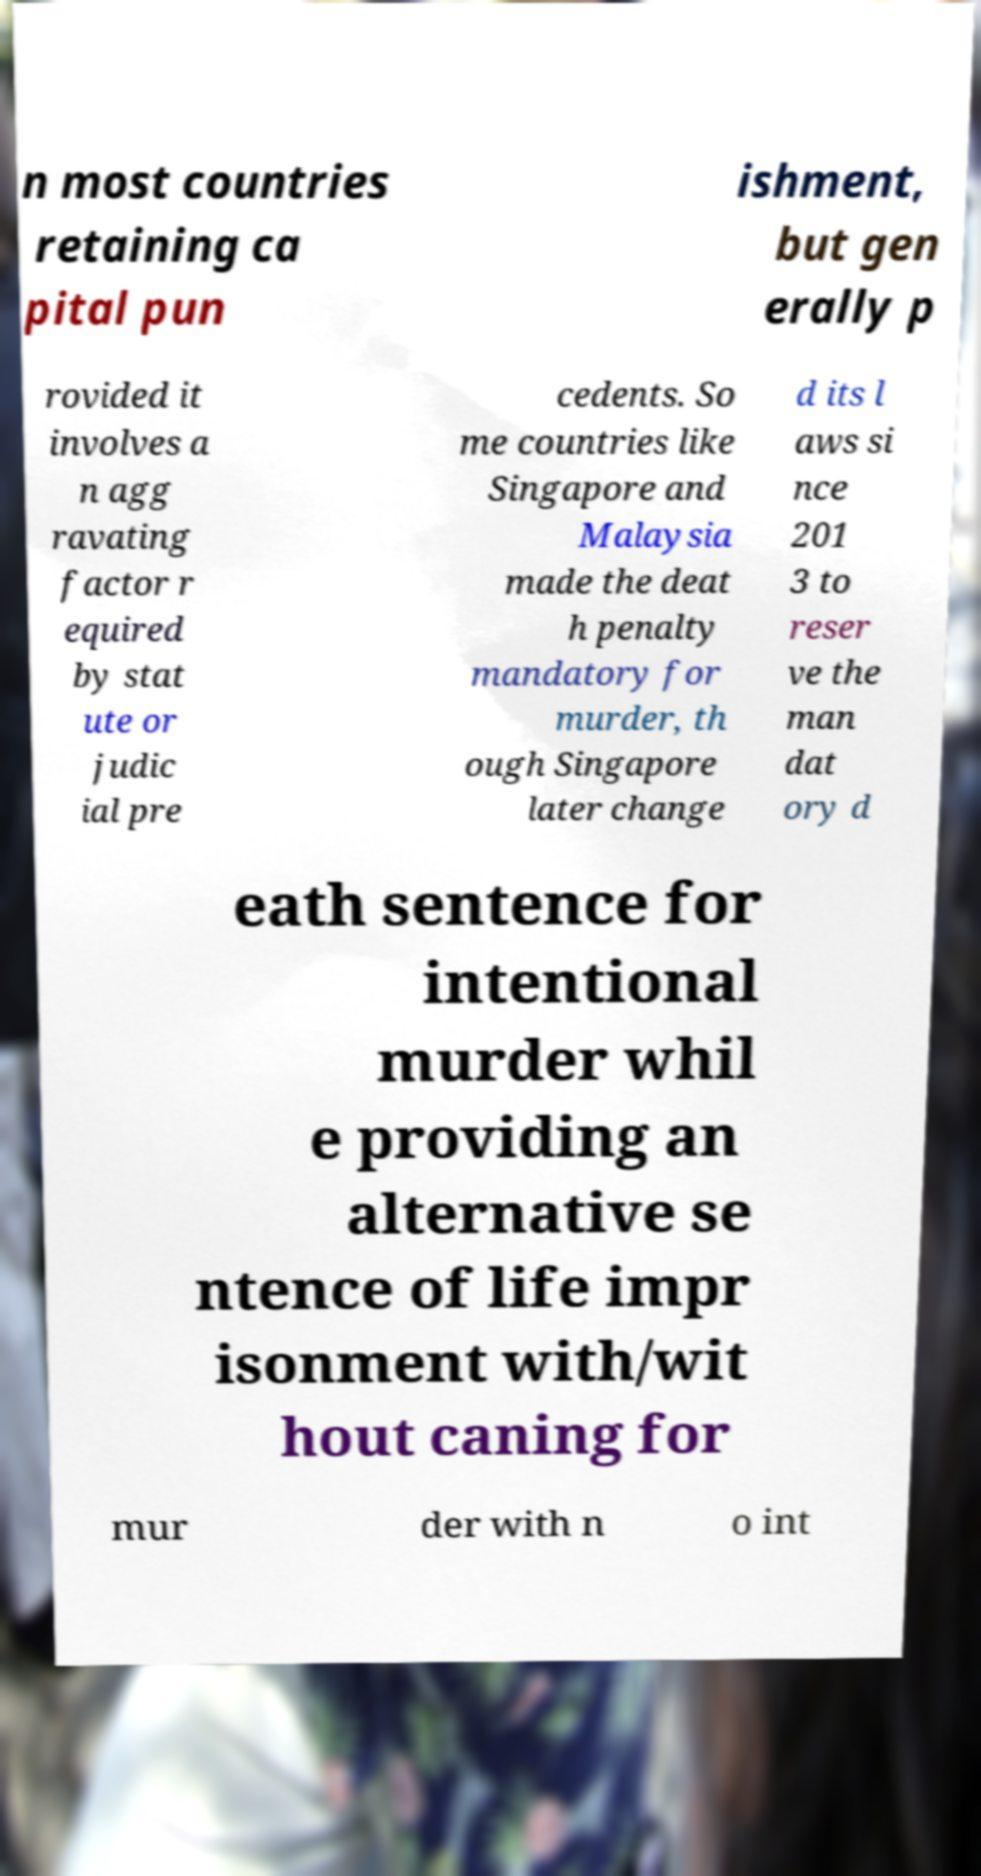Could you assist in decoding the text presented in this image and type it out clearly? n most countries retaining ca pital pun ishment, but gen erally p rovided it involves a n agg ravating factor r equired by stat ute or judic ial pre cedents. So me countries like Singapore and Malaysia made the deat h penalty mandatory for murder, th ough Singapore later change d its l aws si nce 201 3 to reser ve the man dat ory d eath sentence for intentional murder whil e providing an alternative se ntence of life impr isonment with/wit hout caning for mur der with n o int 